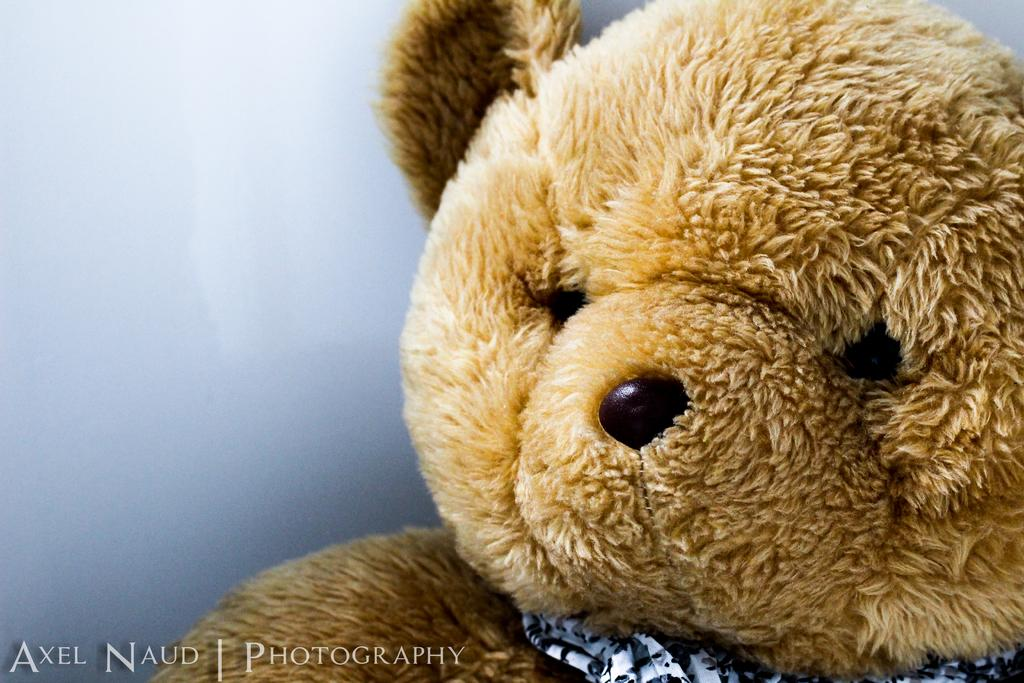What object can be seen in the image? There is a teddy bear in the image. What else is present in the image besides the teddy bear? There is text in the image. How would you describe the color of the background in the image? The background of the image is ash colored. Can you tell if the image was taken in a specific setting? The image may have been taken in a studio. How many toes does the teddy bear have in the image? Teddy bears do not have toes, as they are not living beings and are made of fabric or other materials. 